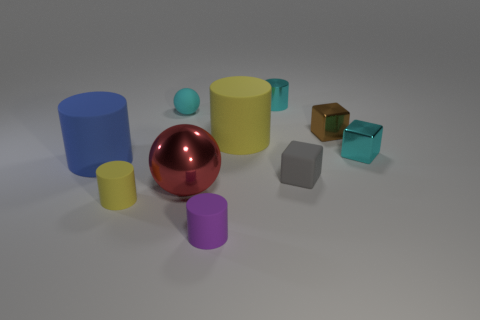Subtract all cyan cylinders. How many cylinders are left? 4 Subtract all metallic cylinders. How many cylinders are left? 4 Subtract 1 cylinders. How many cylinders are left? 4 Subtract all red cylinders. Subtract all gray cubes. How many cylinders are left? 5 Subtract all cubes. How many objects are left? 7 Add 7 red shiny things. How many red shiny things are left? 8 Add 9 tiny gray things. How many tiny gray things exist? 10 Subtract 0 green balls. How many objects are left? 10 Subtract all yellow cylinders. Subtract all gray things. How many objects are left? 7 